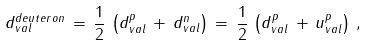Convert formula to latex. <formula><loc_0><loc_0><loc_500><loc_500>d _ { v a l } ^ { d e u t e r o n } \, = \, \frac { 1 } { 2 } \, \left ( d _ { v a l } ^ { p } \, + \, d _ { v a l } ^ { n } \right ) \, = \, \frac { 1 } { 2 } \, \left ( d _ { v a l } ^ { p } \, + \, u _ { v a l } ^ { p } \right ) \, ,</formula> 